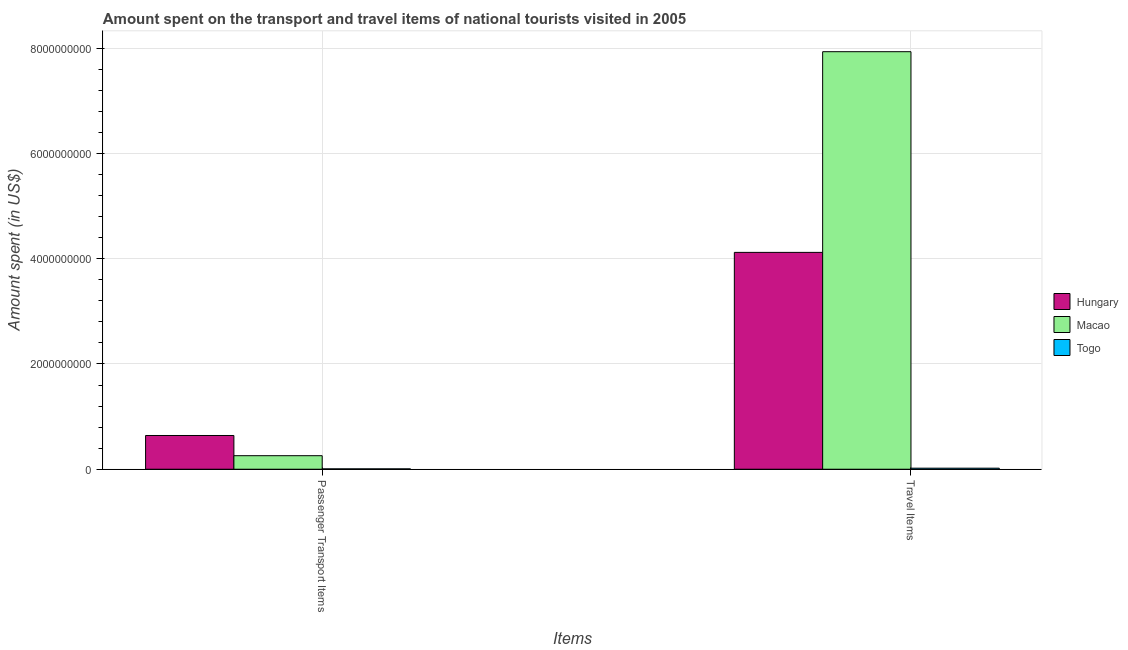How many bars are there on the 2nd tick from the right?
Offer a terse response. 3. What is the label of the 1st group of bars from the left?
Ensure brevity in your answer.  Passenger Transport Items. What is the amount spent in travel items in Togo?
Keep it short and to the point. 2.00e+07. Across all countries, what is the maximum amount spent in travel items?
Provide a succinct answer. 7.93e+09. Across all countries, what is the minimum amount spent on passenger transport items?
Provide a succinct answer. 7.00e+06. In which country was the amount spent on passenger transport items maximum?
Offer a very short reply. Hungary. In which country was the amount spent in travel items minimum?
Provide a short and direct response. Togo. What is the total amount spent on passenger transport items in the graph?
Your response must be concise. 9.05e+08. What is the difference between the amount spent on passenger transport items in Hungary and that in Togo?
Provide a short and direct response. 6.34e+08. What is the difference between the amount spent on passenger transport items in Togo and the amount spent in travel items in Hungary?
Provide a succinct answer. -4.11e+09. What is the average amount spent on passenger transport items per country?
Provide a short and direct response. 3.02e+08. What is the difference between the amount spent in travel items and amount spent on passenger transport items in Macao?
Your answer should be compact. 7.68e+09. What is the ratio of the amount spent on passenger transport items in Macao to that in Hungary?
Offer a very short reply. 0.4. What does the 3rd bar from the left in Passenger Transport Items represents?
Provide a succinct answer. Togo. What does the 2nd bar from the right in Passenger Transport Items represents?
Your response must be concise. Macao. How many bars are there?
Provide a short and direct response. 6. Are all the bars in the graph horizontal?
Provide a short and direct response. No. Where does the legend appear in the graph?
Give a very brief answer. Center right. How many legend labels are there?
Give a very brief answer. 3. How are the legend labels stacked?
Ensure brevity in your answer.  Vertical. What is the title of the graph?
Provide a succinct answer. Amount spent on the transport and travel items of national tourists visited in 2005. Does "Latin America(all income levels)" appear as one of the legend labels in the graph?
Offer a very short reply. No. What is the label or title of the X-axis?
Your answer should be very brief. Items. What is the label or title of the Y-axis?
Ensure brevity in your answer.  Amount spent (in US$). What is the Amount spent (in US$) of Hungary in Passenger Transport Items?
Keep it short and to the point. 6.41e+08. What is the Amount spent (in US$) of Macao in Passenger Transport Items?
Offer a very short reply. 2.57e+08. What is the Amount spent (in US$) in Togo in Passenger Transport Items?
Your answer should be very brief. 7.00e+06. What is the Amount spent (in US$) of Hungary in Travel Items?
Ensure brevity in your answer.  4.12e+09. What is the Amount spent (in US$) in Macao in Travel Items?
Your response must be concise. 7.93e+09. Across all Items, what is the maximum Amount spent (in US$) in Hungary?
Keep it short and to the point. 4.12e+09. Across all Items, what is the maximum Amount spent (in US$) in Macao?
Make the answer very short. 7.93e+09. Across all Items, what is the minimum Amount spent (in US$) of Hungary?
Make the answer very short. 6.41e+08. Across all Items, what is the minimum Amount spent (in US$) of Macao?
Offer a terse response. 2.57e+08. What is the total Amount spent (in US$) of Hungary in the graph?
Keep it short and to the point. 4.76e+09. What is the total Amount spent (in US$) in Macao in the graph?
Ensure brevity in your answer.  8.19e+09. What is the total Amount spent (in US$) of Togo in the graph?
Make the answer very short. 2.70e+07. What is the difference between the Amount spent (in US$) in Hungary in Passenger Transport Items and that in Travel Items?
Ensure brevity in your answer.  -3.48e+09. What is the difference between the Amount spent (in US$) in Macao in Passenger Transport Items and that in Travel Items?
Ensure brevity in your answer.  -7.68e+09. What is the difference between the Amount spent (in US$) of Togo in Passenger Transport Items and that in Travel Items?
Offer a very short reply. -1.30e+07. What is the difference between the Amount spent (in US$) of Hungary in Passenger Transport Items and the Amount spent (in US$) of Macao in Travel Items?
Your answer should be compact. -7.29e+09. What is the difference between the Amount spent (in US$) in Hungary in Passenger Transport Items and the Amount spent (in US$) in Togo in Travel Items?
Keep it short and to the point. 6.21e+08. What is the difference between the Amount spent (in US$) in Macao in Passenger Transport Items and the Amount spent (in US$) in Togo in Travel Items?
Give a very brief answer. 2.37e+08. What is the average Amount spent (in US$) in Hungary per Items?
Your response must be concise. 2.38e+09. What is the average Amount spent (in US$) of Macao per Items?
Make the answer very short. 4.10e+09. What is the average Amount spent (in US$) in Togo per Items?
Keep it short and to the point. 1.35e+07. What is the difference between the Amount spent (in US$) of Hungary and Amount spent (in US$) of Macao in Passenger Transport Items?
Offer a very short reply. 3.84e+08. What is the difference between the Amount spent (in US$) of Hungary and Amount spent (in US$) of Togo in Passenger Transport Items?
Give a very brief answer. 6.34e+08. What is the difference between the Amount spent (in US$) of Macao and Amount spent (in US$) of Togo in Passenger Transport Items?
Your answer should be compact. 2.50e+08. What is the difference between the Amount spent (in US$) of Hungary and Amount spent (in US$) of Macao in Travel Items?
Your response must be concise. -3.81e+09. What is the difference between the Amount spent (in US$) in Hungary and Amount spent (in US$) in Togo in Travel Items?
Give a very brief answer. 4.10e+09. What is the difference between the Amount spent (in US$) in Macao and Amount spent (in US$) in Togo in Travel Items?
Your answer should be very brief. 7.91e+09. What is the ratio of the Amount spent (in US$) of Hungary in Passenger Transport Items to that in Travel Items?
Give a very brief answer. 0.16. What is the ratio of the Amount spent (in US$) of Macao in Passenger Transport Items to that in Travel Items?
Ensure brevity in your answer.  0.03. What is the ratio of the Amount spent (in US$) of Togo in Passenger Transport Items to that in Travel Items?
Give a very brief answer. 0.35. What is the difference between the highest and the second highest Amount spent (in US$) of Hungary?
Ensure brevity in your answer.  3.48e+09. What is the difference between the highest and the second highest Amount spent (in US$) in Macao?
Your response must be concise. 7.68e+09. What is the difference between the highest and the second highest Amount spent (in US$) in Togo?
Your answer should be compact. 1.30e+07. What is the difference between the highest and the lowest Amount spent (in US$) in Hungary?
Your answer should be compact. 3.48e+09. What is the difference between the highest and the lowest Amount spent (in US$) of Macao?
Give a very brief answer. 7.68e+09. What is the difference between the highest and the lowest Amount spent (in US$) of Togo?
Your answer should be very brief. 1.30e+07. 